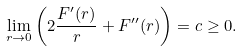<formula> <loc_0><loc_0><loc_500><loc_500>\lim _ { r \rightarrow 0 } \left ( 2 \frac { F ^ { \prime } ( r ) } { r } + F ^ { \prime \prime } ( r ) \right ) = c \geq 0 .</formula> 